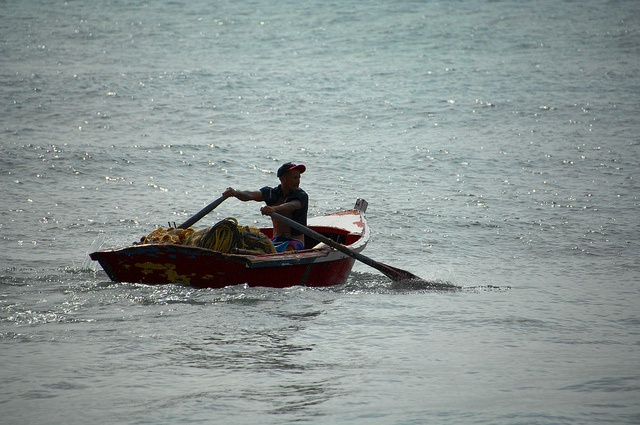Describe the objects in this image and their specific colors. I can see boat in gray, black, lightgray, and maroon tones and people in gray, black, darkgray, and lightgray tones in this image. 